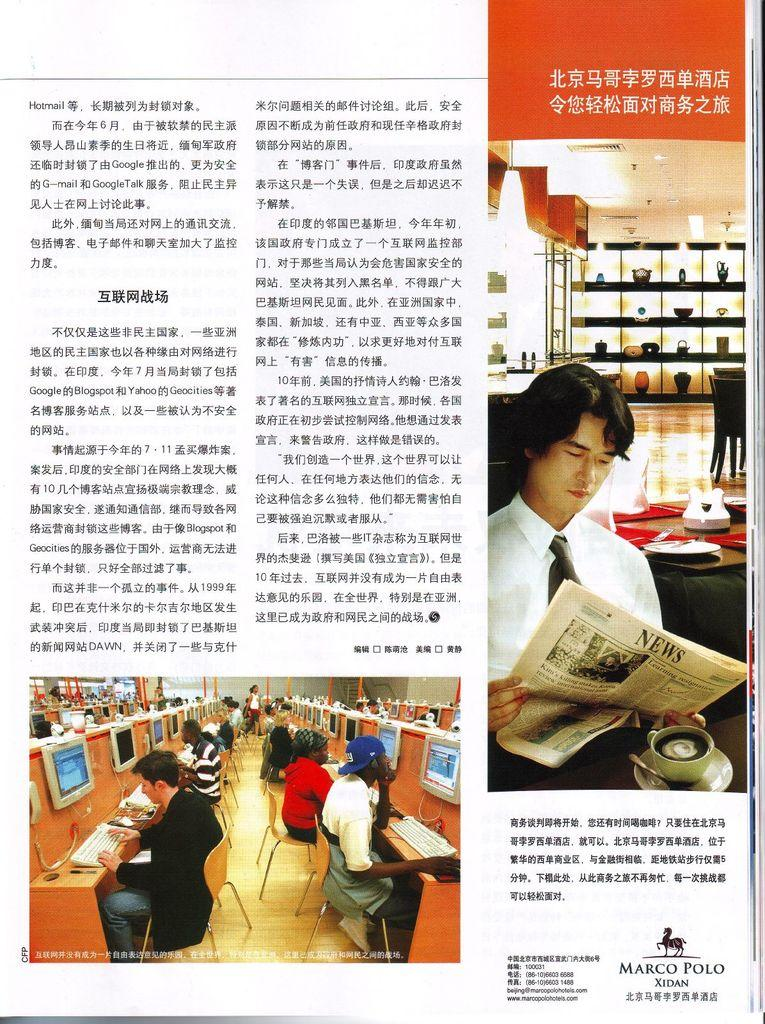<image>
Offer a succinct explanation of the picture presented. The Marco Polo Xidan publication provides a contact email address of beijing@marcopolohotels.com. 